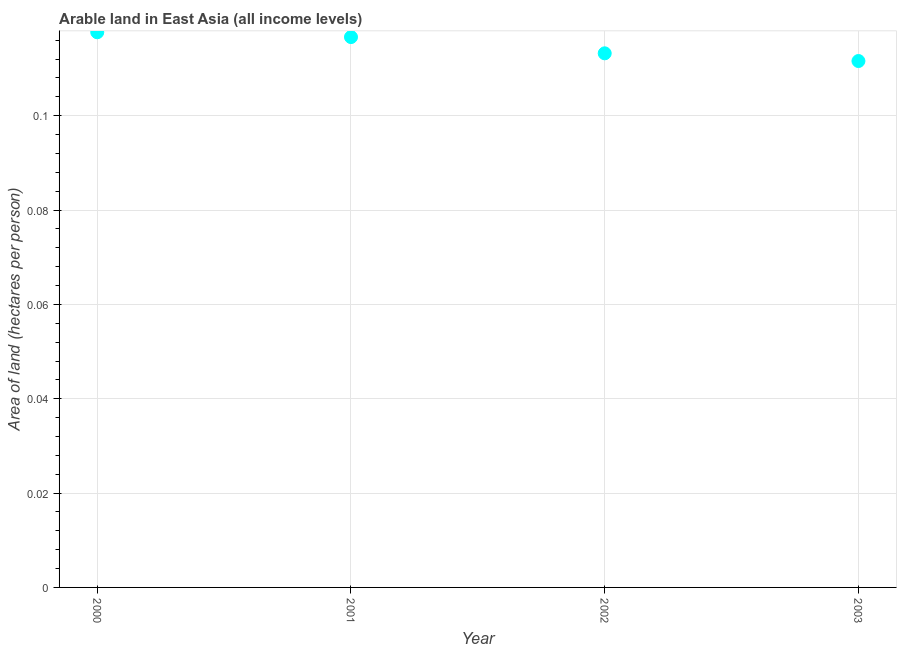What is the area of arable land in 2000?
Your answer should be compact. 0.12. Across all years, what is the maximum area of arable land?
Make the answer very short. 0.12. Across all years, what is the minimum area of arable land?
Provide a succinct answer. 0.11. What is the sum of the area of arable land?
Offer a terse response. 0.46. What is the difference between the area of arable land in 2001 and 2002?
Provide a succinct answer. 0. What is the average area of arable land per year?
Give a very brief answer. 0.11. What is the median area of arable land?
Provide a succinct answer. 0.11. In how many years, is the area of arable land greater than 0.10800000000000001 hectares per person?
Your response must be concise. 4. What is the ratio of the area of arable land in 2000 to that in 2002?
Offer a terse response. 1.04. Is the difference between the area of arable land in 2000 and 2002 greater than the difference between any two years?
Your answer should be very brief. No. What is the difference between the highest and the second highest area of arable land?
Give a very brief answer. 0. What is the difference between the highest and the lowest area of arable land?
Offer a very short reply. 0.01. In how many years, is the area of arable land greater than the average area of arable land taken over all years?
Make the answer very short. 2. How many dotlines are there?
Give a very brief answer. 1. How many years are there in the graph?
Give a very brief answer. 4. What is the difference between two consecutive major ticks on the Y-axis?
Offer a terse response. 0.02. Are the values on the major ticks of Y-axis written in scientific E-notation?
Keep it short and to the point. No. Does the graph contain grids?
Keep it short and to the point. Yes. What is the title of the graph?
Keep it short and to the point. Arable land in East Asia (all income levels). What is the label or title of the X-axis?
Provide a short and direct response. Year. What is the label or title of the Y-axis?
Give a very brief answer. Area of land (hectares per person). What is the Area of land (hectares per person) in 2000?
Your answer should be compact. 0.12. What is the Area of land (hectares per person) in 2001?
Provide a short and direct response. 0.12. What is the Area of land (hectares per person) in 2002?
Provide a succinct answer. 0.11. What is the Area of land (hectares per person) in 2003?
Your answer should be very brief. 0.11. What is the difference between the Area of land (hectares per person) in 2000 and 2001?
Keep it short and to the point. 0. What is the difference between the Area of land (hectares per person) in 2000 and 2002?
Your response must be concise. 0. What is the difference between the Area of land (hectares per person) in 2000 and 2003?
Keep it short and to the point. 0.01. What is the difference between the Area of land (hectares per person) in 2001 and 2002?
Your answer should be very brief. 0. What is the difference between the Area of land (hectares per person) in 2001 and 2003?
Ensure brevity in your answer.  0.01. What is the difference between the Area of land (hectares per person) in 2002 and 2003?
Give a very brief answer. 0. What is the ratio of the Area of land (hectares per person) in 2000 to that in 2001?
Offer a terse response. 1.01. What is the ratio of the Area of land (hectares per person) in 2000 to that in 2002?
Provide a short and direct response. 1.04. What is the ratio of the Area of land (hectares per person) in 2000 to that in 2003?
Your response must be concise. 1.05. What is the ratio of the Area of land (hectares per person) in 2001 to that in 2002?
Make the answer very short. 1.03. What is the ratio of the Area of land (hectares per person) in 2001 to that in 2003?
Provide a short and direct response. 1.05. What is the ratio of the Area of land (hectares per person) in 2002 to that in 2003?
Make the answer very short. 1.01. 